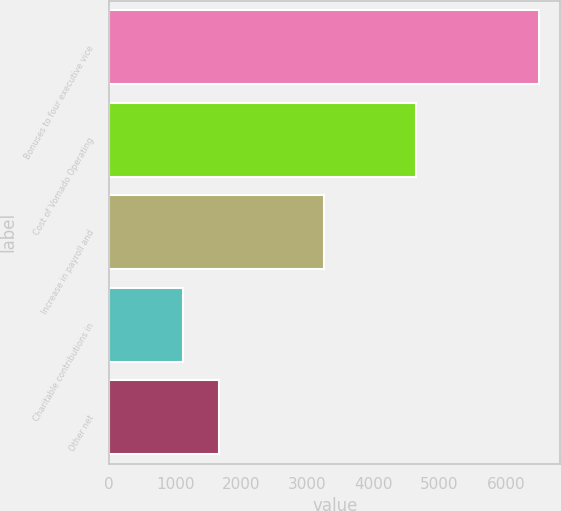Convert chart. <chart><loc_0><loc_0><loc_500><loc_500><bar_chart><fcel>Bonuses to four executive vice<fcel>Cost of Vornado Operating<fcel>Increase in payroll and<fcel>Charitable contributions in<fcel>Other net<nl><fcel>6500<fcel>4643<fcel>3244<fcel>1119<fcel>1657.1<nl></chart> 